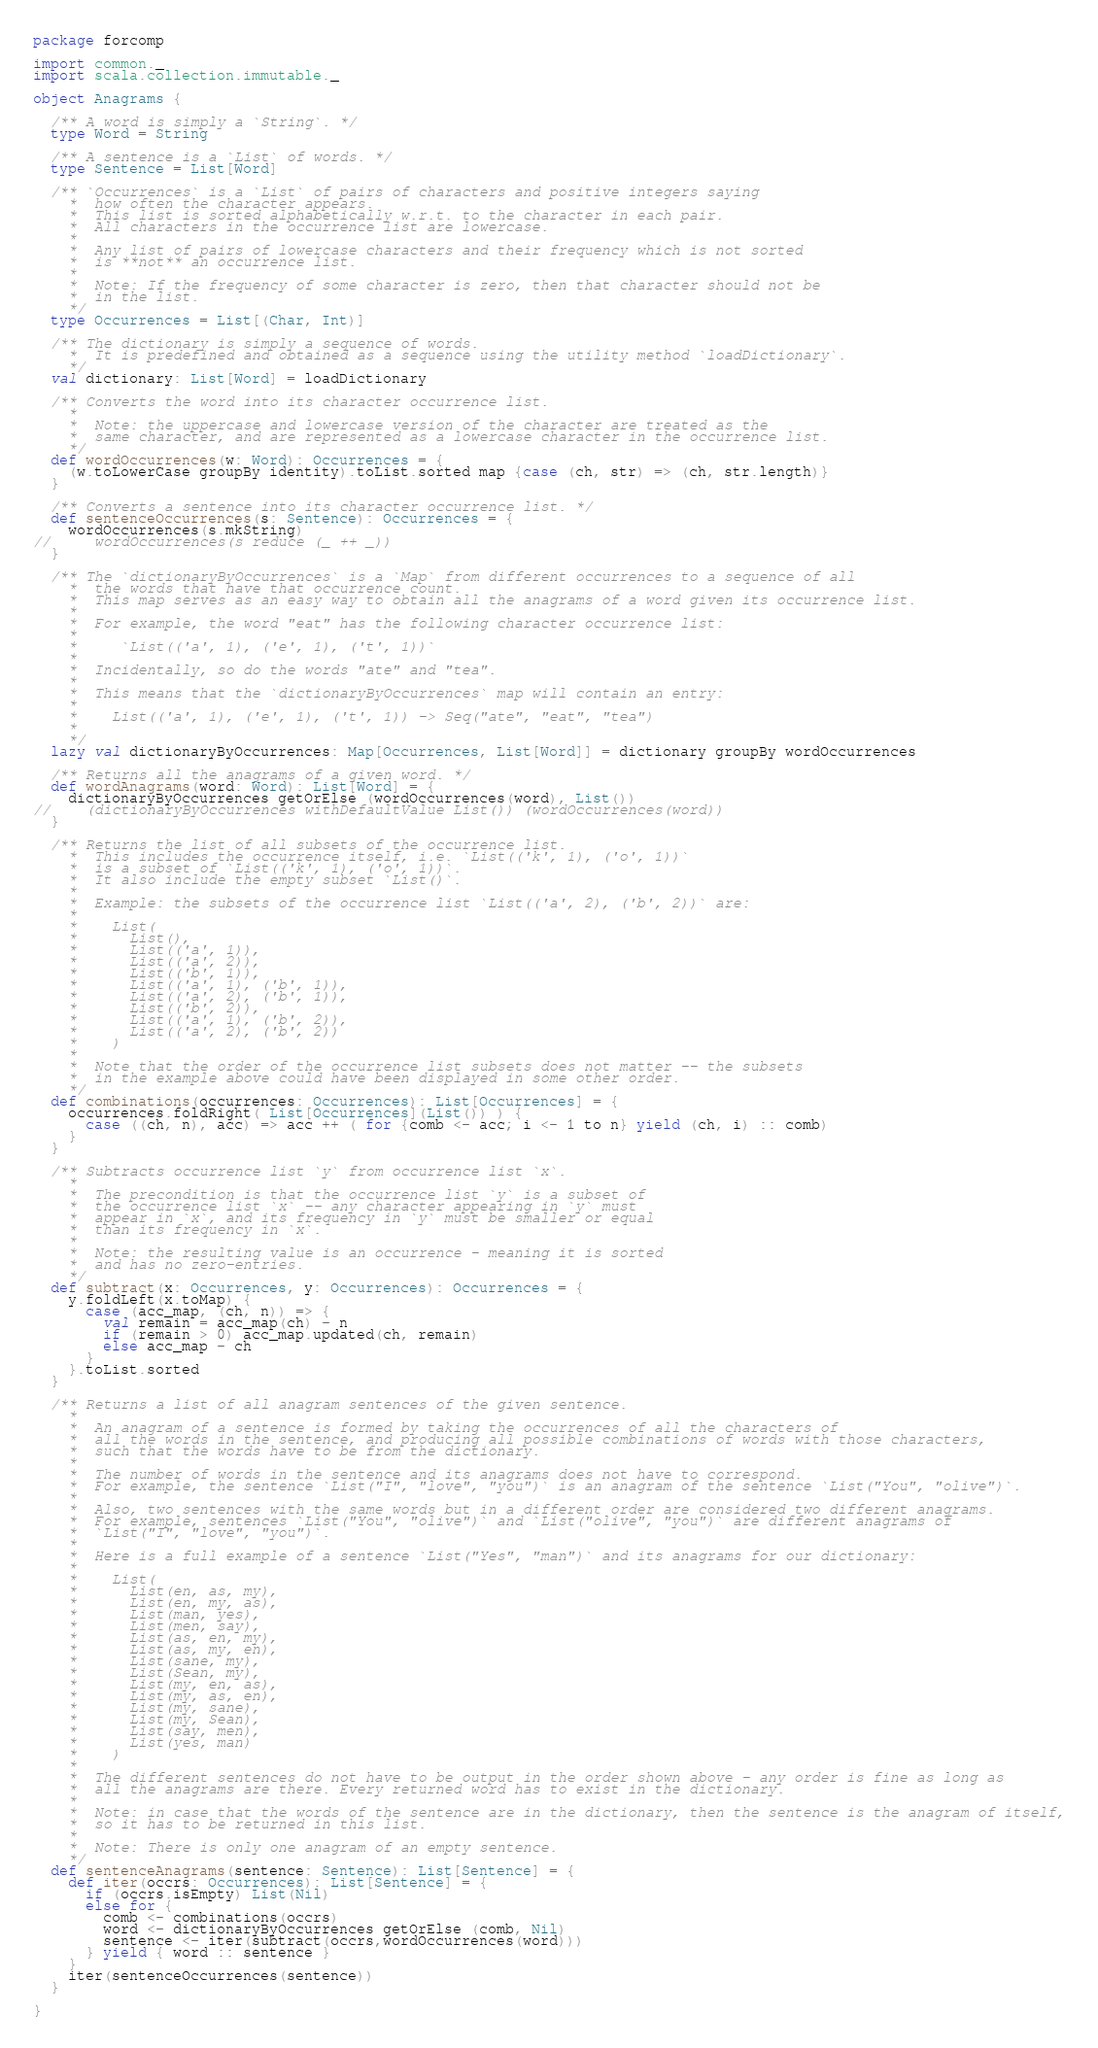<code> <loc_0><loc_0><loc_500><loc_500><_Scala_>package forcomp

import common._
import scala.collection.immutable._

object Anagrams {

  /** A word is simply a `String`. */
  type Word = String

  /** A sentence is a `List` of words. */
  type Sentence = List[Word]

  /** `Occurrences` is a `List` of pairs of characters and positive integers saying
    *  how often the character appears.
    *  This list is sorted alphabetically w.r.t. to the character in each pair.
    *  All characters in the occurrence list are lowercase.
    *
    *  Any list of pairs of lowercase characters and their frequency which is not sorted
    *  is **not** an occurrence list.
    *
    *  Note: If the frequency of some character is zero, then that character should not be
    *  in the list.
    */
  type Occurrences = List[(Char, Int)]

  /** The dictionary is simply a sequence of words.
    *  It is predefined and obtained as a sequence using the utility method `loadDictionary`.
    */
  val dictionary: List[Word] = loadDictionary

  /** Converts the word into its character occurrence list.
    *
    *  Note: the uppercase and lowercase version of the character are treated as the
    *  same character, and are represented as a lowercase character in the occurrence list.
    */
  def wordOccurrences(w: Word): Occurrences = {
    (w.toLowerCase groupBy identity).toList.sorted map {case (ch, str) => (ch, str.length)}
  }

  /** Converts a sentence into its character occurrence list. */
  def sentenceOccurrences(s: Sentence): Occurrences = {
    wordOccurrences(s.mkString)
//     wordOccurrences(s reduce (_ ++ _))
  }

  /** The `dictionaryByOccurrences` is a `Map` from different occurrences to a sequence of all
    *  the words that have that occurrence count.
    *  This map serves as an easy way to obtain all the anagrams of a word given its occurrence list.
    *
    *  For example, the word "eat" has the following character occurrence list:
    *
    *     `List(('a', 1), ('e', 1), ('t', 1))`
    *
    *  Incidentally, so do the words "ate" and "tea".
    *
    *  This means that the `dictionaryByOccurrences` map will contain an entry:
    *
    *    List(('a', 1), ('e', 1), ('t', 1)) -> Seq("ate", "eat", "tea")
    *
    */
  lazy val dictionaryByOccurrences: Map[Occurrences, List[Word]] = dictionary groupBy wordOccurrences

  /** Returns all the anagrams of a given word. */
  def wordAnagrams(word: Word): List[Word] = {
    dictionaryByOccurrences getOrElse (wordOccurrences(word), List())
//    (dictionaryByOccurrences withDefaultValue List()) (wordOccurrences(word))
  }

  /** Returns the list of all subsets of the occurrence list.
    *  This includes the occurrence itself, i.e. `List(('k', 1), ('o', 1))`
    *  is a subset of `List(('k', 1), ('o', 1))`.
    *  It also include the empty subset `List()`.
    *
    *  Example: the subsets of the occurrence list `List(('a', 2), ('b', 2))` are:
    *
    *    List(
    *      List(),
    *      List(('a', 1)),
    *      List(('a', 2)),
    *      List(('b', 1)),
    *      List(('a', 1), ('b', 1)),
    *      List(('a', 2), ('b', 1)),
    *      List(('b', 2)),
    *      List(('a', 1), ('b', 2)),
    *      List(('a', 2), ('b', 2))
    *    )
    *
    *  Note that the order of the occurrence list subsets does not matter -- the subsets
    *  in the example above could have been displayed in some other order.
    */
  def combinations(occurrences: Occurrences): List[Occurrences] = {
    occurrences.foldRight( List[Occurrences](List()) ) {
      case ((ch, n), acc) => acc ++ ( for {comb <- acc; i <- 1 to n} yield (ch, i) :: comb)
    }
  }

  /** Subtracts occurrence list `y` from occurrence list `x`.
    *
    *  The precondition is that the occurrence list `y` is a subset of
    *  the occurrence list `x` -- any character appearing in `y` must
    *  appear in `x`, and its frequency in `y` must be smaller or equal
    *  than its frequency in `x`.
    *
    *  Note: the resulting value is an occurrence - meaning it is sorted
    *  and has no zero-entries.
    */
  def subtract(x: Occurrences, y: Occurrences): Occurrences = {
    y.foldLeft(x.toMap) {
      case (acc_map, (ch, n)) => {
        val remain = acc_map(ch) - n
        if (remain > 0) acc_map.updated(ch, remain)
        else acc_map - ch
      }
    }.toList.sorted
  }

  /** Returns a list of all anagram sentences of the given sentence.
    *
    *  An anagram of a sentence is formed by taking the occurrences of all the characters of
    *  all the words in the sentence, and producing all possible combinations of words with those characters,
    *  such that the words have to be from the dictionary.
    *
    *  The number of words in the sentence and its anagrams does not have to correspond.
    *  For example, the sentence `List("I", "love", "you")` is an anagram of the sentence `List("You", "olive")`.
    *
    *  Also, two sentences with the same words but in a different order are considered two different anagrams.
    *  For example, sentences `List("You", "olive")` and `List("olive", "you")` are different anagrams of
    *  `List("I", "love", "you")`.
    *
    *  Here is a full example of a sentence `List("Yes", "man")` and its anagrams for our dictionary:
    *
    *    List(
    *      List(en, as, my),
    *      List(en, my, as),
    *      List(man, yes),
    *      List(men, say),
    *      List(as, en, my),
    *      List(as, my, en),
    *      List(sane, my),
    *      List(Sean, my),
    *      List(my, en, as),
    *      List(my, as, en),
    *      List(my, sane),
    *      List(my, Sean),
    *      List(say, men),
    *      List(yes, man)
    *    )
    *
    *  The different sentences do not have to be output in the order shown above - any order is fine as long as
    *  all the anagrams are there. Every returned word has to exist in the dictionary.
    *
    *  Note: in case that the words of the sentence are in the dictionary, then the sentence is the anagram of itself,
    *  so it has to be returned in this list.
    *
    *  Note: There is only one anagram of an empty sentence.
    */
  def sentenceAnagrams(sentence: Sentence): List[Sentence] = {
    def iter(occrs: Occurrences): List[Sentence] = {
      if (occrs.isEmpty) List(Nil)
      else for {
        comb <- combinations(occrs)
        word <- dictionaryByOccurrences getOrElse (comb, Nil)
        sentence <- iter(subtract(occrs,wordOccurrences(word)))
      } yield { word :: sentence }
    }
    iter(sentenceOccurrences(sentence))
  }

}
</code> 